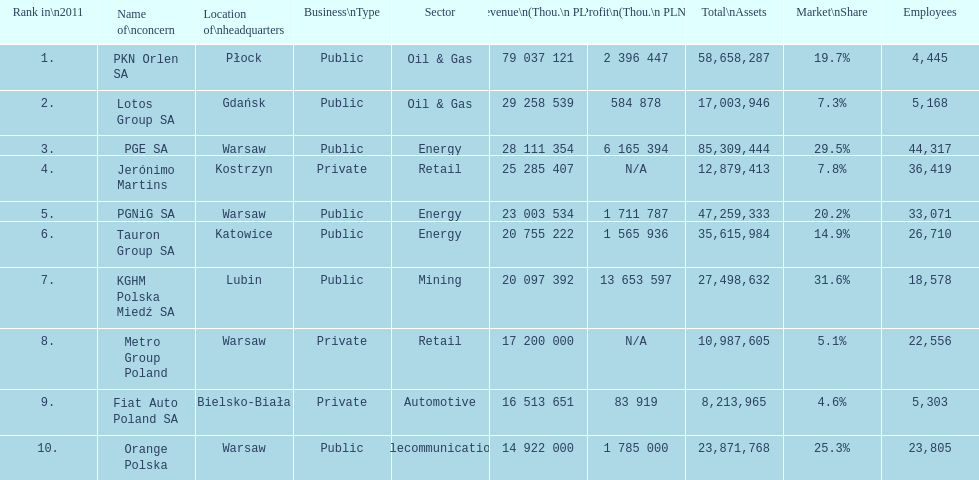Which company had the least revenue? Orange Polska. 